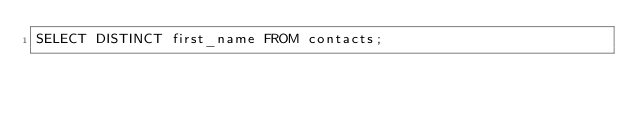<code> <loc_0><loc_0><loc_500><loc_500><_SQL_>SELECT DISTINCT first_name FROM contacts;</code> 